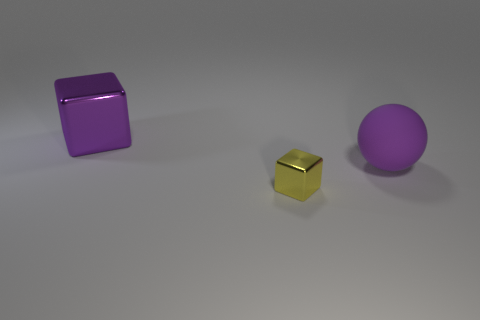What might be the relative sizes of these objects in comparison to each other? In comparison, the purple cube on the left is the largest object. The small gold cube in the middle is the smallest, with each side being significantly shorter than the edges of the other two objects. The purple sphere on the right is slightly smaller than the purple cube but larger than the golden cube, making it the medium-sized object among the three. 